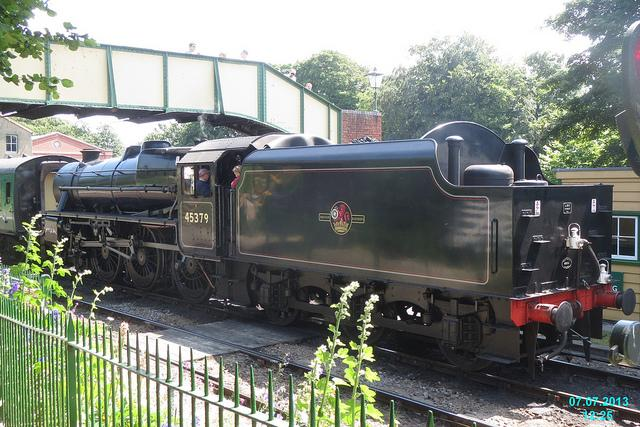What sort of traffic is allowed on the bridge over this train? Please explain your reasoning. foot. The little bridge is too small to support vehicles, and by the many heads visible over the top of it, it is open only to pedestrians. 